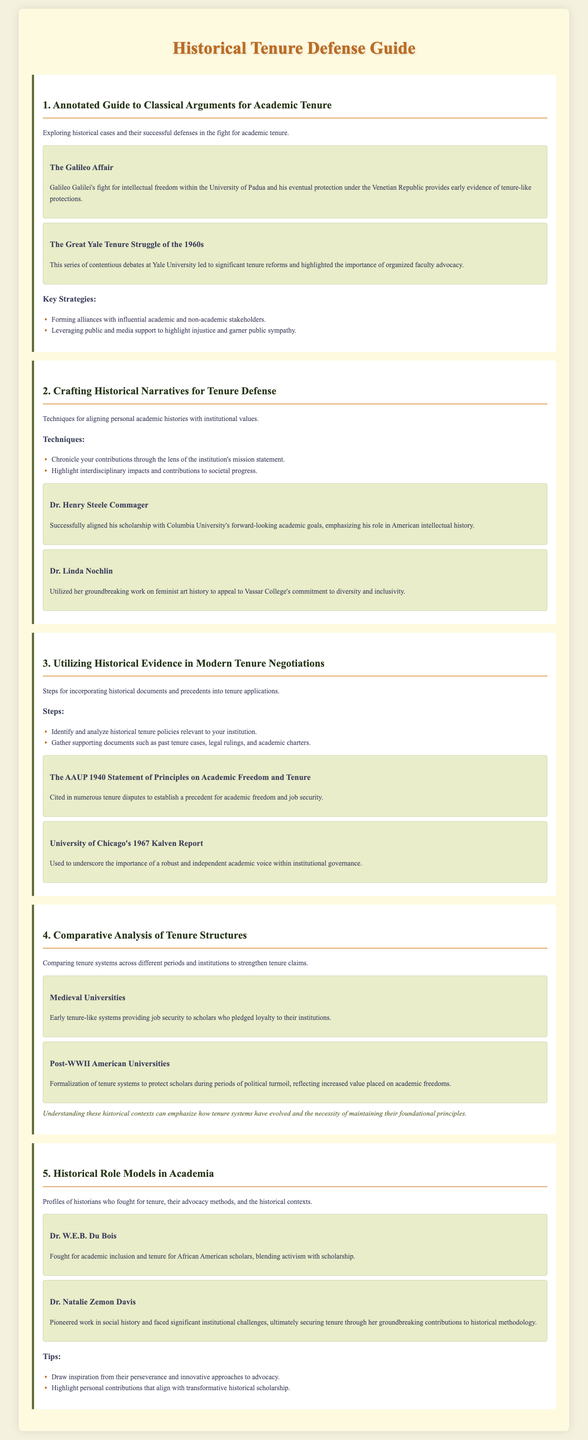What is the title of the document? The title of the document is provided in the header of the HTML as "Historical Tenure Defense Guide."
Answer: Historical Tenure Defense Guide Who was involved in the Galileo Affair? The document mentions Galileo Galilei's involvement in the Galileo Affair related to the University of Padua.
Answer: Galileo Galilei Which notable case study is associated with Columbia University? The document highlights Dr. Henry Steele Commager's successful alignment of his scholarship with Columbia University.
Answer: Dr. Henry Steele Commager What important document is cited in tenure disputes? The document refers to the "AAUP 1940 Statement of Principles on Academic Freedom and Tenure."
Answer: AAUP 1940 Statement What two historical academic contexts are mentioned? The document discusses Medieval Universities and Post-WWII American Universities in the comparative analysis section.
Answer: Medieval Universities and Post-WWII American Universities Who fought for tenure for African American scholars? The document outlines Dr. W.E.B. Du Bois's efforts for academic inclusion and tenure for African American scholars.
Answer: Dr. W.E.B. Du Bois How many key strategies are listed for classical arguments for academic tenure? The document lists two key strategies under the classical arguments section for tenure defense.
Answer: Two What year was the Kalven Report published? Although the document does not explicitly state the year, the Kalven Report is known to have been published in 1967.
Answer: 1967 What is a tip for historical role models in academia? The document provides the tip to draw inspiration from their perseverance and innovative approaches to advocacy.
Answer: Draw inspiration from their perseverance 